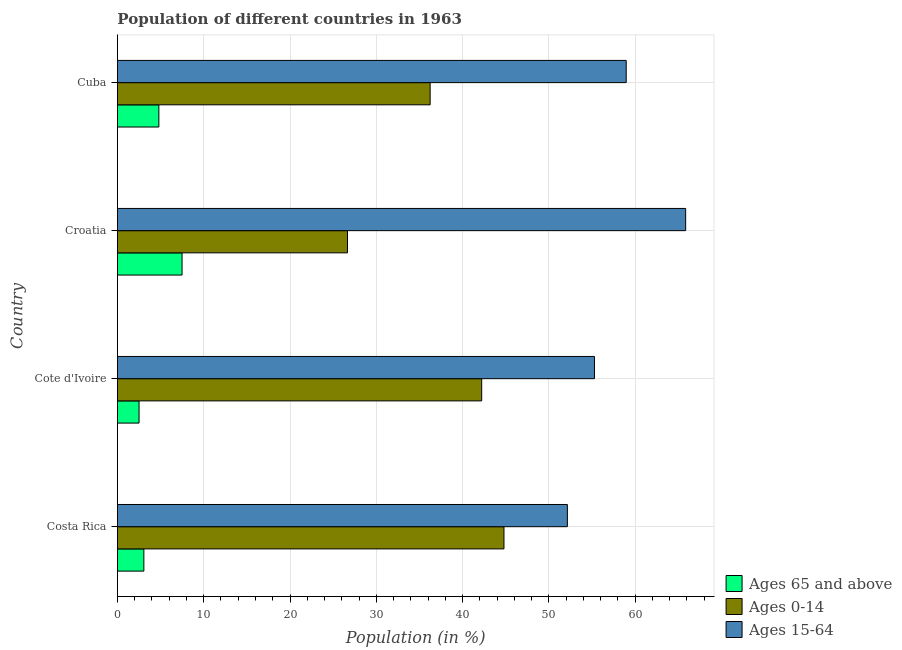How many groups of bars are there?
Your response must be concise. 4. Are the number of bars per tick equal to the number of legend labels?
Your answer should be compact. Yes. How many bars are there on the 2nd tick from the bottom?
Offer a very short reply. 3. What is the label of the 3rd group of bars from the top?
Keep it short and to the point. Cote d'Ivoire. In how many cases, is the number of bars for a given country not equal to the number of legend labels?
Give a very brief answer. 0. What is the percentage of population within the age-group 0-14 in Croatia?
Provide a short and direct response. 26.66. Across all countries, what is the maximum percentage of population within the age-group 15-64?
Your answer should be very brief. 65.85. Across all countries, what is the minimum percentage of population within the age-group 0-14?
Your answer should be very brief. 26.66. In which country was the percentage of population within the age-group of 65 and above maximum?
Make the answer very short. Croatia. In which country was the percentage of population within the age-group of 65 and above minimum?
Provide a succinct answer. Cote d'Ivoire. What is the total percentage of population within the age-group of 65 and above in the graph?
Keep it short and to the point. 17.87. What is the difference between the percentage of population within the age-group 15-64 in Croatia and that in Cuba?
Your answer should be very brief. 6.89. What is the difference between the percentage of population within the age-group 15-64 in Costa Rica and the percentage of population within the age-group 0-14 in Cote d'Ivoire?
Provide a short and direct response. 9.93. What is the average percentage of population within the age-group 15-64 per country?
Provide a succinct answer. 58.06. What is the difference between the percentage of population within the age-group 0-14 and percentage of population within the age-group of 65 and above in Croatia?
Offer a terse response. 19.17. In how many countries, is the percentage of population within the age-group 0-14 greater than 62 %?
Offer a terse response. 0. What is the ratio of the percentage of population within the age-group of 65 and above in Costa Rica to that in Croatia?
Keep it short and to the point. 0.41. Is the difference between the percentage of population within the age-group 0-14 in Costa Rica and Cote d'Ivoire greater than the difference between the percentage of population within the age-group 15-64 in Costa Rica and Cote d'Ivoire?
Give a very brief answer. Yes. What is the difference between the highest and the second highest percentage of population within the age-group 0-14?
Provide a succinct answer. 2.58. What is the difference between the highest and the lowest percentage of population within the age-group 15-64?
Make the answer very short. 13.71. In how many countries, is the percentage of population within the age-group 0-14 greater than the average percentage of population within the age-group 0-14 taken over all countries?
Give a very brief answer. 2. Is the sum of the percentage of population within the age-group 0-14 in Cote d'Ivoire and Cuba greater than the maximum percentage of population within the age-group 15-64 across all countries?
Keep it short and to the point. Yes. What does the 1st bar from the top in Cote d'Ivoire represents?
Offer a very short reply. Ages 15-64. What does the 1st bar from the bottom in Cuba represents?
Offer a terse response. Ages 65 and above. Is it the case that in every country, the sum of the percentage of population within the age-group of 65 and above and percentage of population within the age-group 0-14 is greater than the percentage of population within the age-group 15-64?
Give a very brief answer. No. How many bars are there?
Provide a short and direct response. 12. How many countries are there in the graph?
Offer a terse response. 4. What is the difference between two consecutive major ticks on the X-axis?
Your response must be concise. 10. How many legend labels are there?
Your answer should be very brief. 3. How are the legend labels stacked?
Make the answer very short. Vertical. What is the title of the graph?
Offer a terse response. Population of different countries in 1963. Does "Infant(female)" appear as one of the legend labels in the graph?
Provide a succinct answer. No. What is the Population (in %) in Ages 65 and above in Costa Rica?
Make the answer very short. 3.07. What is the Population (in %) in Ages 0-14 in Costa Rica?
Keep it short and to the point. 44.79. What is the Population (in %) in Ages 15-64 in Costa Rica?
Offer a terse response. 52.14. What is the Population (in %) of Ages 65 and above in Cote d'Ivoire?
Keep it short and to the point. 2.51. What is the Population (in %) in Ages 0-14 in Cote d'Ivoire?
Offer a very short reply. 42.21. What is the Population (in %) of Ages 15-64 in Cote d'Ivoire?
Your answer should be compact. 55.28. What is the Population (in %) of Ages 65 and above in Croatia?
Ensure brevity in your answer.  7.49. What is the Population (in %) of Ages 0-14 in Croatia?
Your answer should be very brief. 26.66. What is the Population (in %) of Ages 15-64 in Croatia?
Your response must be concise. 65.85. What is the Population (in %) in Ages 65 and above in Cuba?
Ensure brevity in your answer.  4.8. What is the Population (in %) in Ages 0-14 in Cuba?
Provide a succinct answer. 36.24. What is the Population (in %) in Ages 15-64 in Cuba?
Provide a short and direct response. 58.96. Across all countries, what is the maximum Population (in %) of Ages 65 and above?
Give a very brief answer. 7.49. Across all countries, what is the maximum Population (in %) in Ages 0-14?
Your answer should be very brief. 44.79. Across all countries, what is the maximum Population (in %) in Ages 15-64?
Ensure brevity in your answer.  65.85. Across all countries, what is the minimum Population (in %) of Ages 65 and above?
Ensure brevity in your answer.  2.51. Across all countries, what is the minimum Population (in %) in Ages 0-14?
Offer a terse response. 26.66. Across all countries, what is the minimum Population (in %) in Ages 15-64?
Your answer should be very brief. 52.14. What is the total Population (in %) of Ages 65 and above in the graph?
Offer a very short reply. 17.87. What is the total Population (in %) of Ages 0-14 in the graph?
Your answer should be compact. 149.9. What is the total Population (in %) of Ages 15-64 in the graph?
Offer a terse response. 232.23. What is the difference between the Population (in %) in Ages 65 and above in Costa Rica and that in Cote d'Ivoire?
Your answer should be compact. 0.56. What is the difference between the Population (in %) of Ages 0-14 in Costa Rica and that in Cote d'Ivoire?
Offer a terse response. 2.58. What is the difference between the Population (in %) in Ages 15-64 in Costa Rica and that in Cote d'Ivoire?
Make the answer very short. -3.14. What is the difference between the Population (in %) of Ages 65 and above in Costa Rica and that in Croatia?
Your response must be concise. -4.43. What is the difference between the Population (in %) in Ages 0-14 in Costa Rica and that in Croatia?
Offer a very short reply. 18.13. What is the difference between the Population (in %) in Ages 15-64 in Costa Rica and that in Croatia?
Your answer should be very brief. -13.71. What is the difference between the Population (in %) of Ages 65 and above in Costa Rica and that in Cuba?
Ensure brevity in your answer.  -1.74. What is the difference between the Population (in %) in Ages 0-14 in Costa Rica and that in Cuba?
Your answer should be compact. 8.55. What is the difference between the Population (in %) in Ages 15-64 in Costa Rica and that in Cuba?
Make the answer very short. -6.82. What is the difference between the Population (in %) in Ages 65 and above in Cote d'Ivoire and that in Croatia?
Provide a short and direct response. -4.98. What is the difference between the Population (in %) in Ages 0-14 in Cote d'Ivoire and that in Croatia?
Ensure brevity in your answer.  15.55. What is the difference between the Population (in %) in Ages 15-64 in Cote d'Ivoire and that in Croatia?
Your response must be concise. -10.57. What is the difference between the Population (in %) of Ages 65 and above in Cote d'Ivoire and that in Cuba?
Your answer should be compact. -2.29. What is the difference between the Population (in %) in Ages 0-14 in Cote d'Ivoire and that in Cuba?
Provide a short and direct response. 5.97. What is the difference between the Population (in %) of Ages 15-64 in Cote d'Ivoire and that in Cuba?
Give a very brief answer. -3.68. What is the difference between the Population (in %) in Ages 65 and above in Croatia and that in Cuba?
Ensure brevity in your answer.  2.69. What is the difference between the Population (in %) in Ages 0-14 in Croatia and that in Cuba?
Offer a terse response. -9.58. What is the difference between the Population (in %) in Ages 15-64 in Croatia and that in Cuba?
Offer a very short reply. 6.89. What is the difference between the Population (in %) in Ages 65 and above in Costa Rica and the Population (in %) in Ages 0-14 in Cote d'Ivoire?
Your answer should be compact. -39.15. What is the difference between the Population (in %) in Ages 65 and above in Costa Rica and the Population (in %) in Ages 15-64 in Cote d'Ivoire?
Keep it short and to the point. -52.21. What is the difference between the Population (in %) in Ages 0-14 in Costa Rica and the Population (in %) in Ages 15-64 in Cote d'Ivoire?
Offer a very short reply. -10.49. What is the difference between the Population (in %) in Ages 65 and above in Costa Rica and the Population (in %) in Ages 0-14 in Croatia?
Keep it short and to the point. -23.6. What is the difference between the Population (in %) in Ages 65 and above in Costa Rica and the Population (in %) in Ages 15-64 in Croatia?
Give a very brief answer. -62.78. What is the difference between the Population (in %) in Ages 0-14 in Costa Rica and the Population (in %) in Ages 15-64 in Croatia?
Keep it short and to the point. -21.05. What is the difference between the Population (in %) of Ages 65 and above in Costa Rica and the Population (in %) of Ages 0-14 in Cuba?
Offer a terse response. -33.17. What is the difference between the Population (in %) of Ages 65 and above in Costa Rica and the Population (in %) of Ages 15-64 in Cuba?
Provide a succinct answer. -55.89. What is the difference between the Population (in %) in Ages 0-14 in Costa Rica and the Population (in %) in Ages 15-64 in Cuba?
Ensure brevity in your answer.  -14.17. What is the difference between the Population (in %) in Ages 65 and above in Cote d'Ivoire and the Population (in %) in Ages 0-14 in Croatia?
Your answer should be compact. -24.15. What is the difference between the Population (in %) of Ages 65 and above in Cote d'Ivoire and the Population (in %) of Ages 15-64 in Croatia?
Provide a succinct answer. -63.34. What is the difference between the Population (in %) of Ages 0-14 in Cote d'Ivoire and the Population (in %) of Ages 15-64 in Croatia?
Provide a succinct answer. -23.63. What is the difference between the Population (in %) in Ages 65 and above in Cote d'Ivoire and the Population (in %) in Ages 0-14 in Cuba?
Make the answer very short. -33.73. What is the difference between the Population (in %) of Ages 65 and above in Cote d'Ivoire and the Population (in %) of Ages 15-64 in Cuba?
Provide a short and direct response. -56.45. What is the difference between the Population (in %) in Ages 0-14 in Cote d'Ivoire and the Population (in %) in Ages 15-64 in Cuba?
Your answer should be very brief. -16.75. What is the difference between the Population (in %) in Ages 65 and above in Croatia and the Population (in %) in Ages 0-14 in Cuba?
Your response must be concise. -28.75. What is the difference between the Population (in %) of Ages 65 and above in Croatia and the Population (in %) of Ages 15-64 in Cuba?
Your answer should be very brief. -51.47. What is the difference between the Population (in %) of Ages 0-14 in Croatia and the Population (in %) of Ages 15-64 in Cuba?
Your response must be concise. -32.3. What is the average Population (in %) of Ages 65 and above per country?
Your answer should be very brief. 4.47. What is the average Population (in %) of Ages 0-14 per country?
Your answer should be very brief. 37.48. What is the average Population (in %) of Ages 15-64 per country?
Your answer should be compact. 58.06. What is the difference between the Population (in %) in Ages 65 and above and Population (in %) in Ages 0-14 in Costa Rica?
Your answer should be very brief. -41.73. What is the difference between the Population (in %) of Ages 65 and above and Population (in %) of Ages 15-64 in Costa Rica?
Give a very brief answer. -49.08. What is the difference between the Population (in %) in Ages 0-14 and Population (in %) in Ages 15-64 in Costa Rica?
Keep it short and to the point. -7.35. What is the difference between the Population (in %) of Ages 65 and above and Population (in %) of Ages 0-14 in Cote d'Ivoire?
Your answer should be very brief. -39.7. What is the difference between the Population (in %) in Ages 65 and above and Population (in %) in Ages 15-64 in Cote d'Ivoire?
Give a very brief answer. -52.77. What is the difference between the Population (in %) in Ages 0-14 and Population (in %) in Ages 15-64 in Cote d'Ivoire?
Give a very brief answer. -13.07. What is the difference between the Population (in %) of Ages 65 and above and Population (in %) of Ages 0-14 in Croatia?
Keep it short and to the point. -19.17. What is the difference between the Population (in %) in Ages 65 and above and Population (in %) in Ages 15-64 in Croatia?
Provide a succinct answer. -58.35. What is the difference between the Population (in %) of Ages 0-14 and Population (in %) of Ages 15-64 in Croatia?
Your response must be concise. -39.18. What is the difference between the Population (in %) in Ages 65 and above and Population (in %) in Ages 0-14 in Cuba?
Ensure brevity in your answer.  -31.43. What is the difference between the Population (in %) of Ages 65 and above and Population (in %) of Ages 15-64 in Cuba?
Ensure brevity in your answer.  -54.15. What is the difference between the Population (in %) in Ages 0-14 and Population (in %) in Ages 15-64 in Cuba?
Give a very brief answer. -22.72. What is the ratio of the Population (in %) of Ages 65 and above in Costa Rica to that in Cote d'Ivoire?
Ensure brevity in your answer.  1.22. What is the ratio of the Population (in %) in Ages 0-14 in Costa Rica to that in Cote d'Ivoire?
Offer a terse response. 1.06. What is the ratio of the Population (in %) in Ages 15-64 in Costa Rica to that in Cote d'Ivoire?
Offer a terse response. 0.94. What is the ratio of the Population (in %) in Ages 65 and above in Costa Rica to that in Croatia?
Your answer should be compact. 0.41. What is the ratio of the Population (in %) in Ages 0-14 in Costa Rica to that in Croatia?
Your answer should be very brief. 1.68. What is the ratio of the Population (in %) of Ages 15-64 in Costa Rica to that in Croatia?
Your answer should be compact. 0.79. What is the ratio of the Population (in %) in Ages 65 and above in Costa Rica to that in Cuba?
Your answer should be very brief. 0.64. What is the ratio of the Population (in %) in Ages 0-14 in Costa Rica to that in Cuba?
Your answer should be compact. 1.24. What is the ratio of the Population (in %) of Ages 15-64 in Costa Rica to that in Cuba?
Offer a very short reply. 0.88. What is the ratio of the Population (in %) of Ages 65 and above in Cote d'Ivoire to that in Croatia?
Your answer should be compact. 0.33. What is the ratio of the Population (in %) of Ages 0-14 in Cote d'Ivoire to that in Croatia?
Your answer should be compact. 1.58. What is the ratio of the Population (in %) in Ages 15-64 in Cote d'Ivoire to that in Croatia?
Your answer should be compact. 0.84. What is the ratio of the Population (in %) in Ages 65 and above in Cote d'Ivoire to that in Cuba?
Provide a succinct answer. 0.52. What is the ratio of the Population (in %) in Ages 0-14 in Cote d'Ivoire to that in Cuba?
Provide a short and direct response. 1.16. What is the ratio of the Population (in %) of Ages 15-64 in Cote d'Ivoire to that in Cuba?
Your response must be concise. 0.94. What is the ratio of the Population (in %) of Ages 65 and above in Croatia to that in Cuba?
Give a very brief answer. 1.56. What is the ratio of the Population (in %) in Ages 0-14 in Croatia to that in Cuba?
Provide a short and direct response. 0.74. What is the ratio of the Population (in %) in Ages 15-64 in Croatia to that in Cuba?
Make the answer very short. 1.12. What is the difference between the highest and the second highest Population (in %) of Ages 65 and above?
Provide a succinct answer. 2.69. What is the difference between the highest and the second highest Population (in %) of Ages 0-14?
Make the answer very short. 2.58. What is the difference between the highest and the second highest Population (in %) in Ages 15-64?
Make the answer very short. 6.89. What is the difference between the highest and the lowest Population (in %) in Ages 65 and above?
Your answer should be very brief. 4.98. What is the difference between the highest and the lowest Population (in %) in Ages 0-14?
Make the answer very short. 18.13. What is the difference between the highest and the lowest Population (in %) in Ages 15-64?
Make the answer very short. 13.71. 